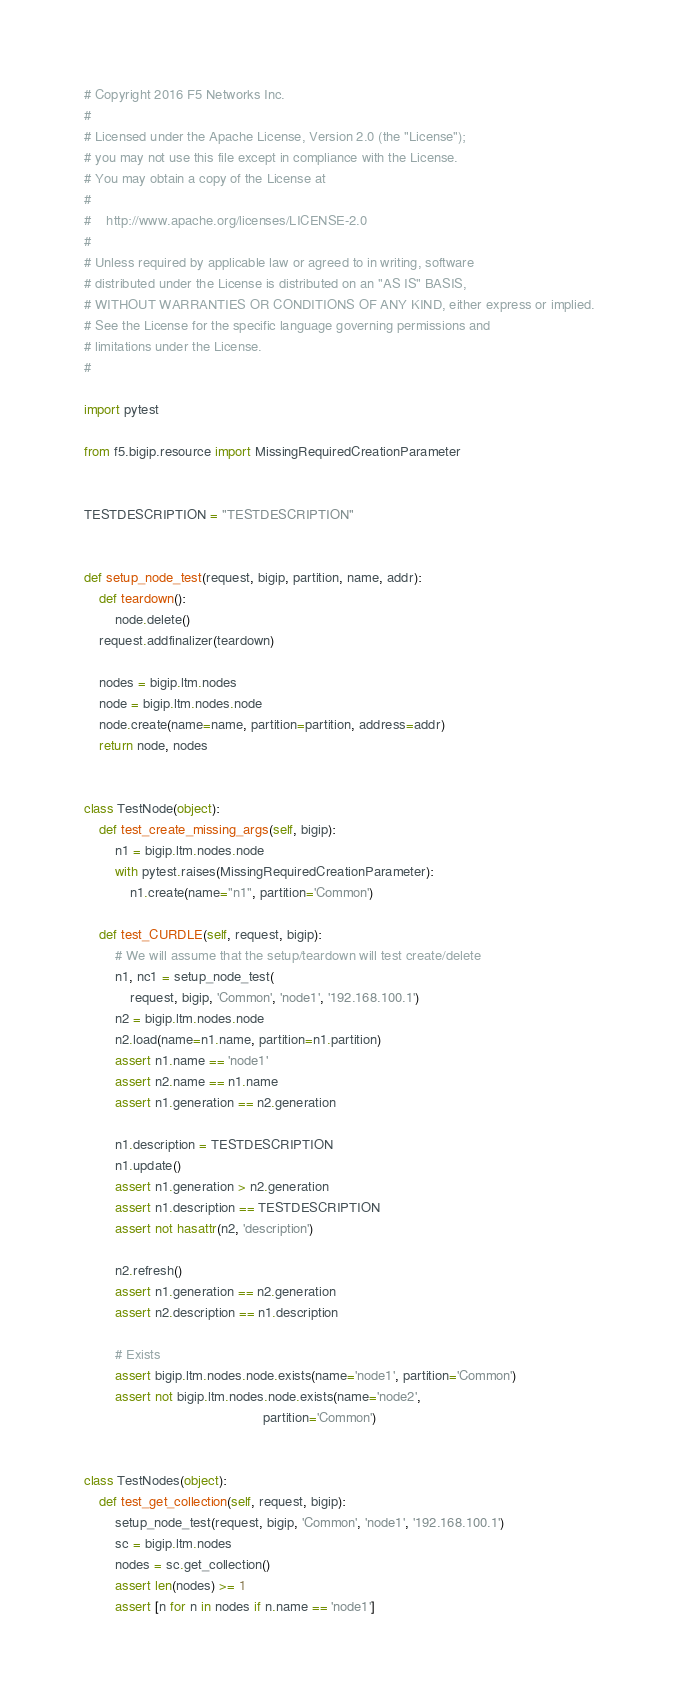Convert code to text. <code><loc_0><loc_0><loc_500><loc_500><_Python_># Copyright 2016 F5 Networks Inc.
#
# Licensed under the Apache License, Version 2.0 (the "License");
# you may not use this file except in compliance with the License.
# You may obtain a copy of the License at
#
#    http://www.apache.org/licenses/LICENSE-2.0
#
# Unless required by applicable law or agreed to in writing, software
# distributed under the License is distributed on an "AS IS" BASIS,
# WITHOUT WARRANTIES OR CONDITIONS OF ANY KIND, either express or implied.
# See the License for the specific language governing permissions and
# limitations under the License.
#

import pytest

from f5.bigip.resource import MissingRequiredCreationParameter


TESTDESCRIPTION = "TESTDESCRIPTION"


def setup_node_test(request, bigip, partition, name, addr):
    def teardown():
        node.delete()
    request.addfinalizer(teardown)

    nodes = bigip.ltm.nodes
    node = bigip.ltm.nodes.node
    node.create(name=name, partition=partition, address=addr)
    return node, nodes


class TestNode(object):
    def test_create_missing_args(self, bigip):
        n1 = bigip.ltm.nodes.node
        with pytest.raises(MissingRequiredCreationParameter):
            n1.create(name="n1", partition='Common')

    def test_CURDLE(self, request, bigip):
        # We will assume that the setup/teardown will test create/delete
        n1, nc1 = setup_node_test(
            request, bigip, 'Common', 'node1', '192.168.100.1')
        n2 = bigip.ltm.nodes.node
        n2.load(name=n1.name, partition=n1.partition)
        assert n1.name == 'node1'
        assert n2.name == n1.name
        assert n1.generation == n2.generation

        n1.description = TESTDESCRIPTION
        n1.update()
        assert n1.generation > n2.generation
        assert n1.description == TESTDESCRIPTION
        assert not hasattr(n2, 'description')

        n2.refresh()
        assert n1.generation == n2.generation
        assert n2.description == n1.description

        # Exists
        assert bigip.ltm.nodes.node.exists(name='node1', partition='Common')
        assert not bigip.ltm.nodes.node.exists(name='node2',
                                               partition='Common')


class TestNodes(object):
    def test_get_collection(self, request, bigip):
        setup_node_test(request, bigip, 'Common', 'node1', '192.168.100.1')
        sc = bigip.ltm.nodes
        nodes = sc.get_collection()
        assert len(nodes) >= 1
        assert [n for n in nodes if n.name == 'node1']
</code> 